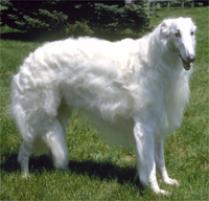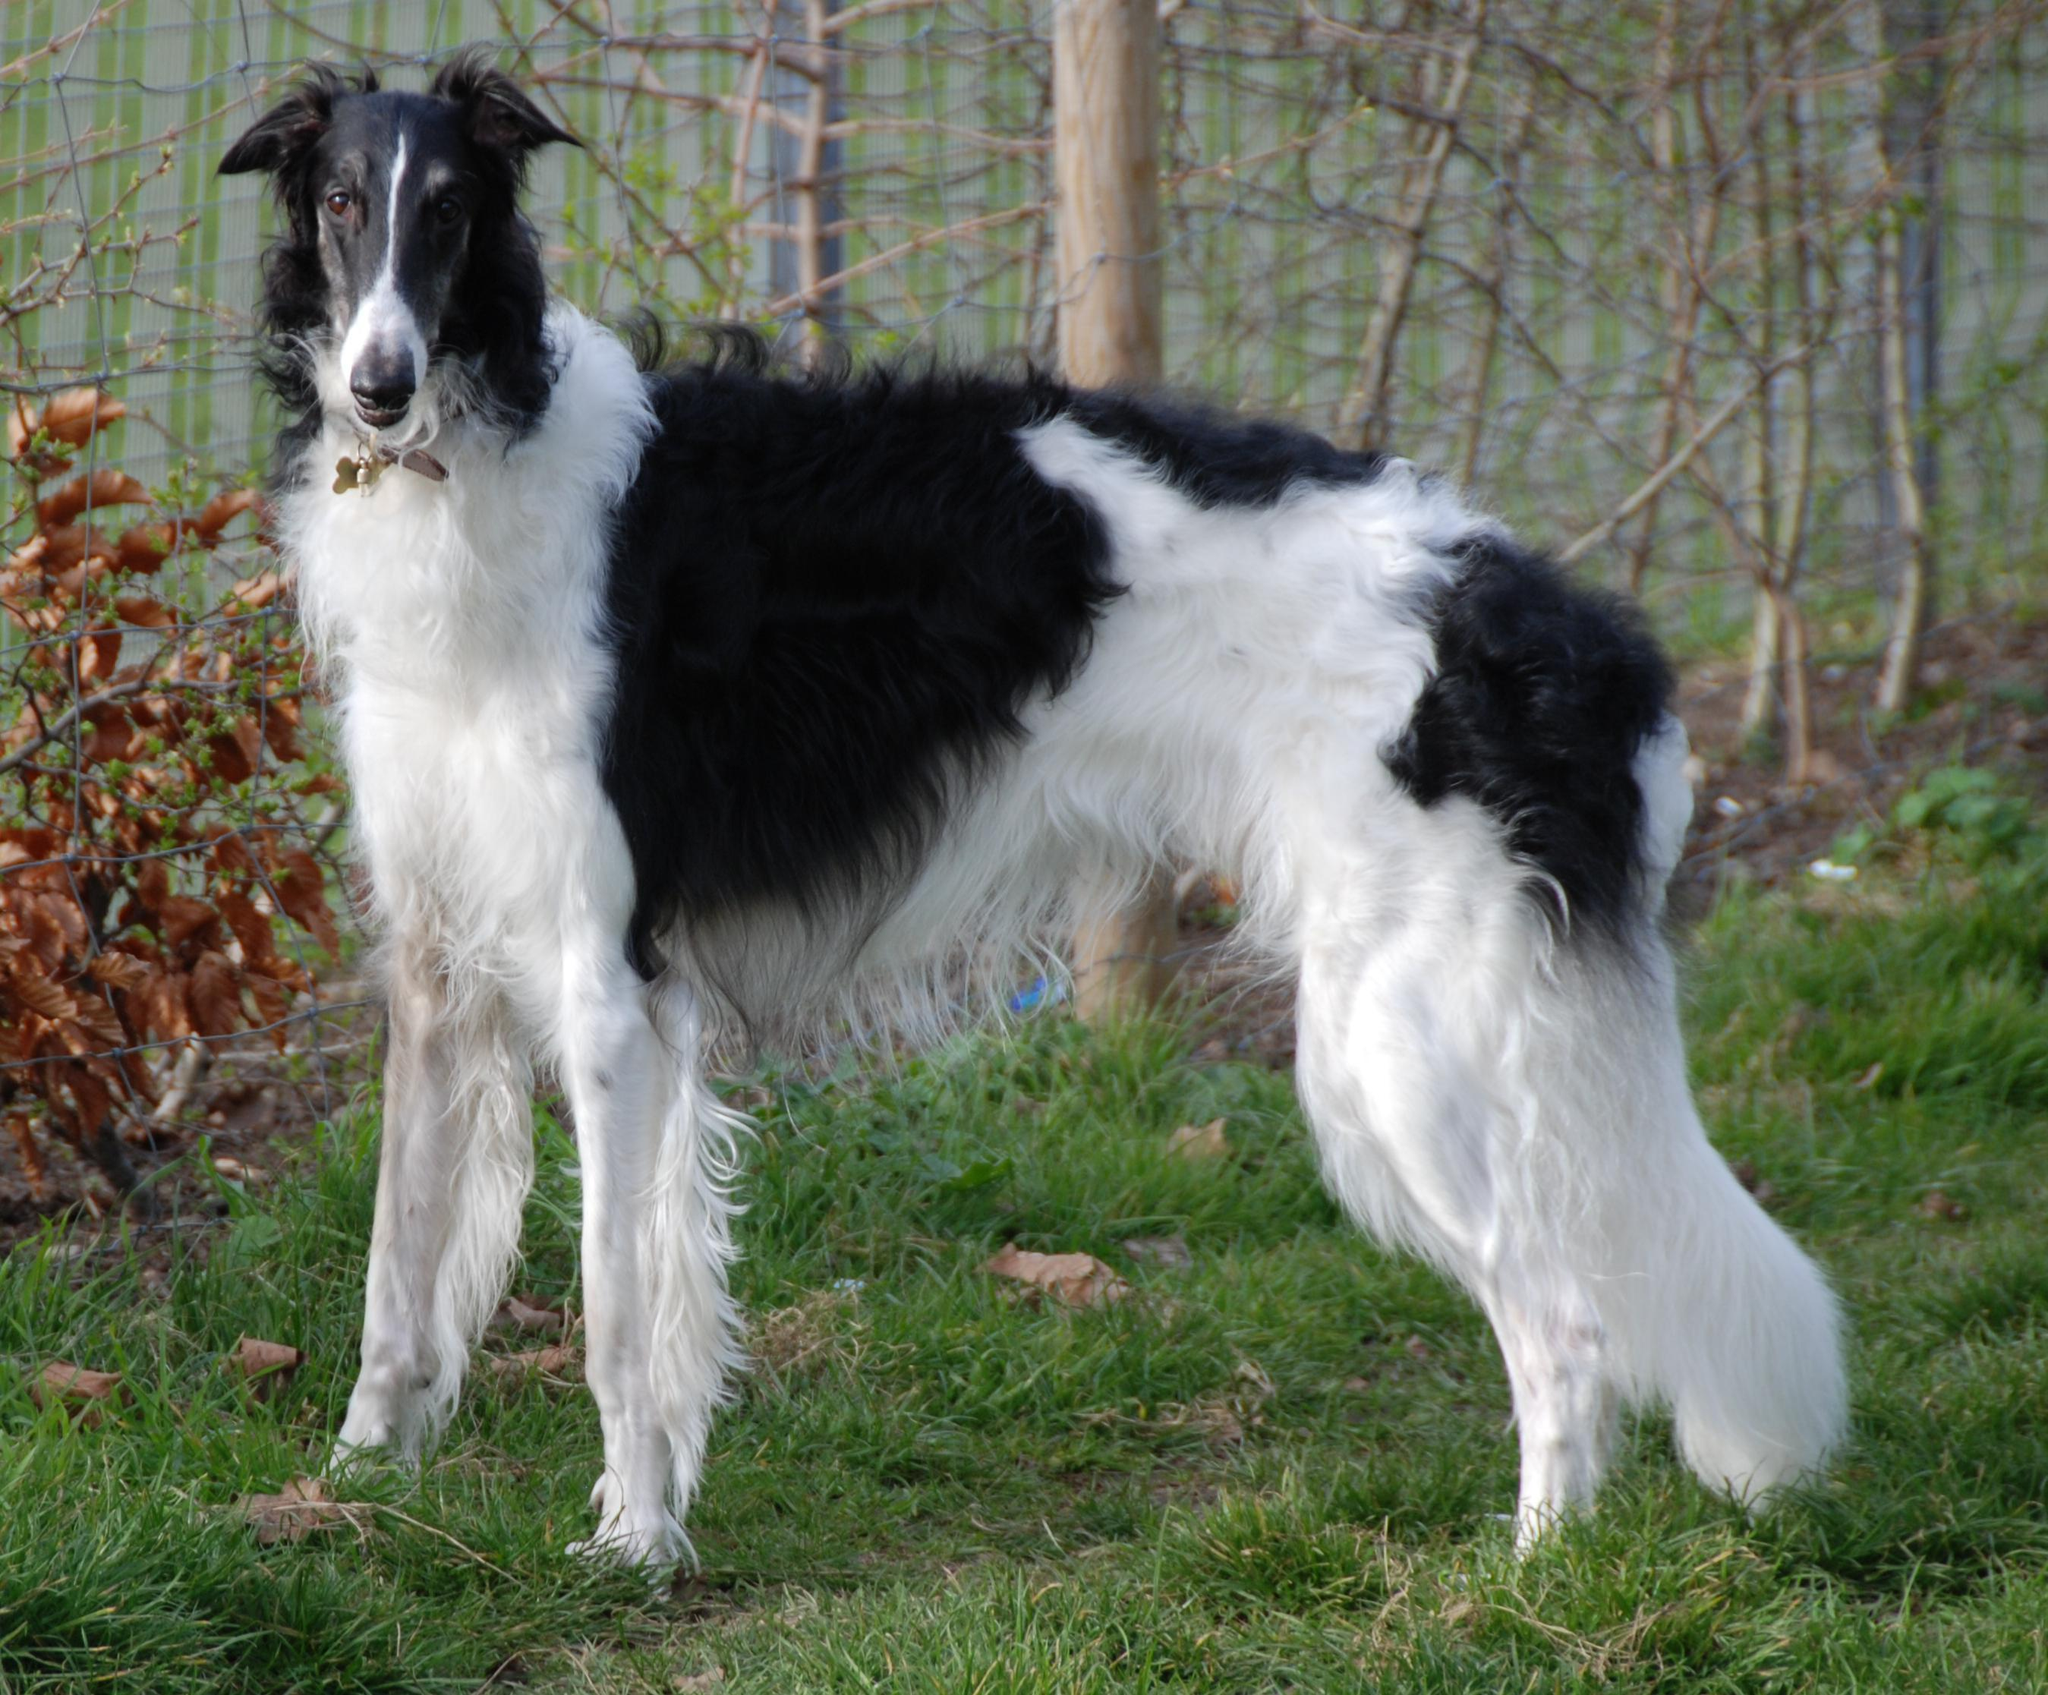The first image is the image on the left, the second image is the image on the right. Assess this claim about the two images: "There is more than one dog in the image on the left.". Correct or not? Answer yes or no. No. 